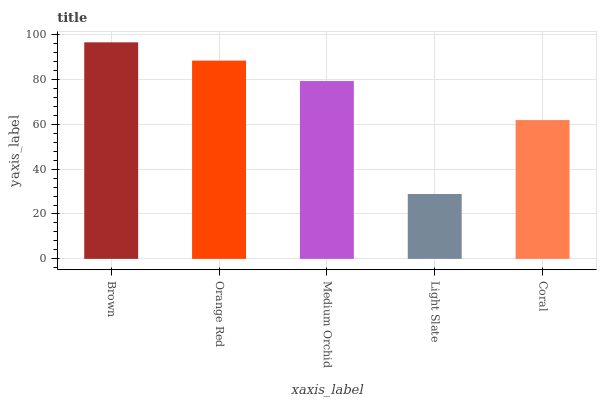Is Light Slate the minimum?
Answer yes or no. Yes. Is Brown the maximum?
Answer yes or no. Yes. Is Orange Red the minimum?
Answer yes or no. No. Is Orange Red the maximum?
Answer yes or no. No. Is Brown greater than Orange Red?
Answer yes or no. Yes. Is Orange Red less than Brown?
Answer yes or no. Yes. Is Orange Red greater than Brown?
Answer yes or no. No. Is Brown less than Orange Red?
Answer yes or no. No. Is Medium Orchid the high median?
Answer yes or no. Yes. Is Medium Orchid the low median?
Answer yes or no. Yes. Is Coral the high median?
Answer yes or no. No. Is Light Slate the low median?
Answer yes or no. No. 